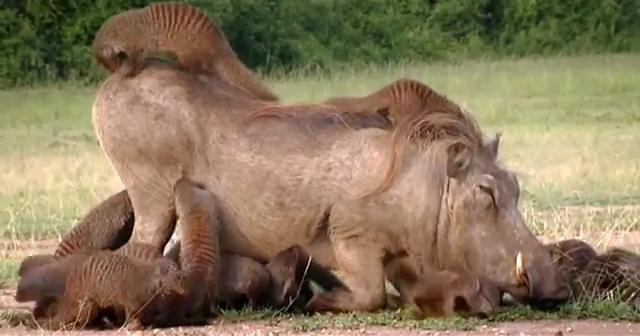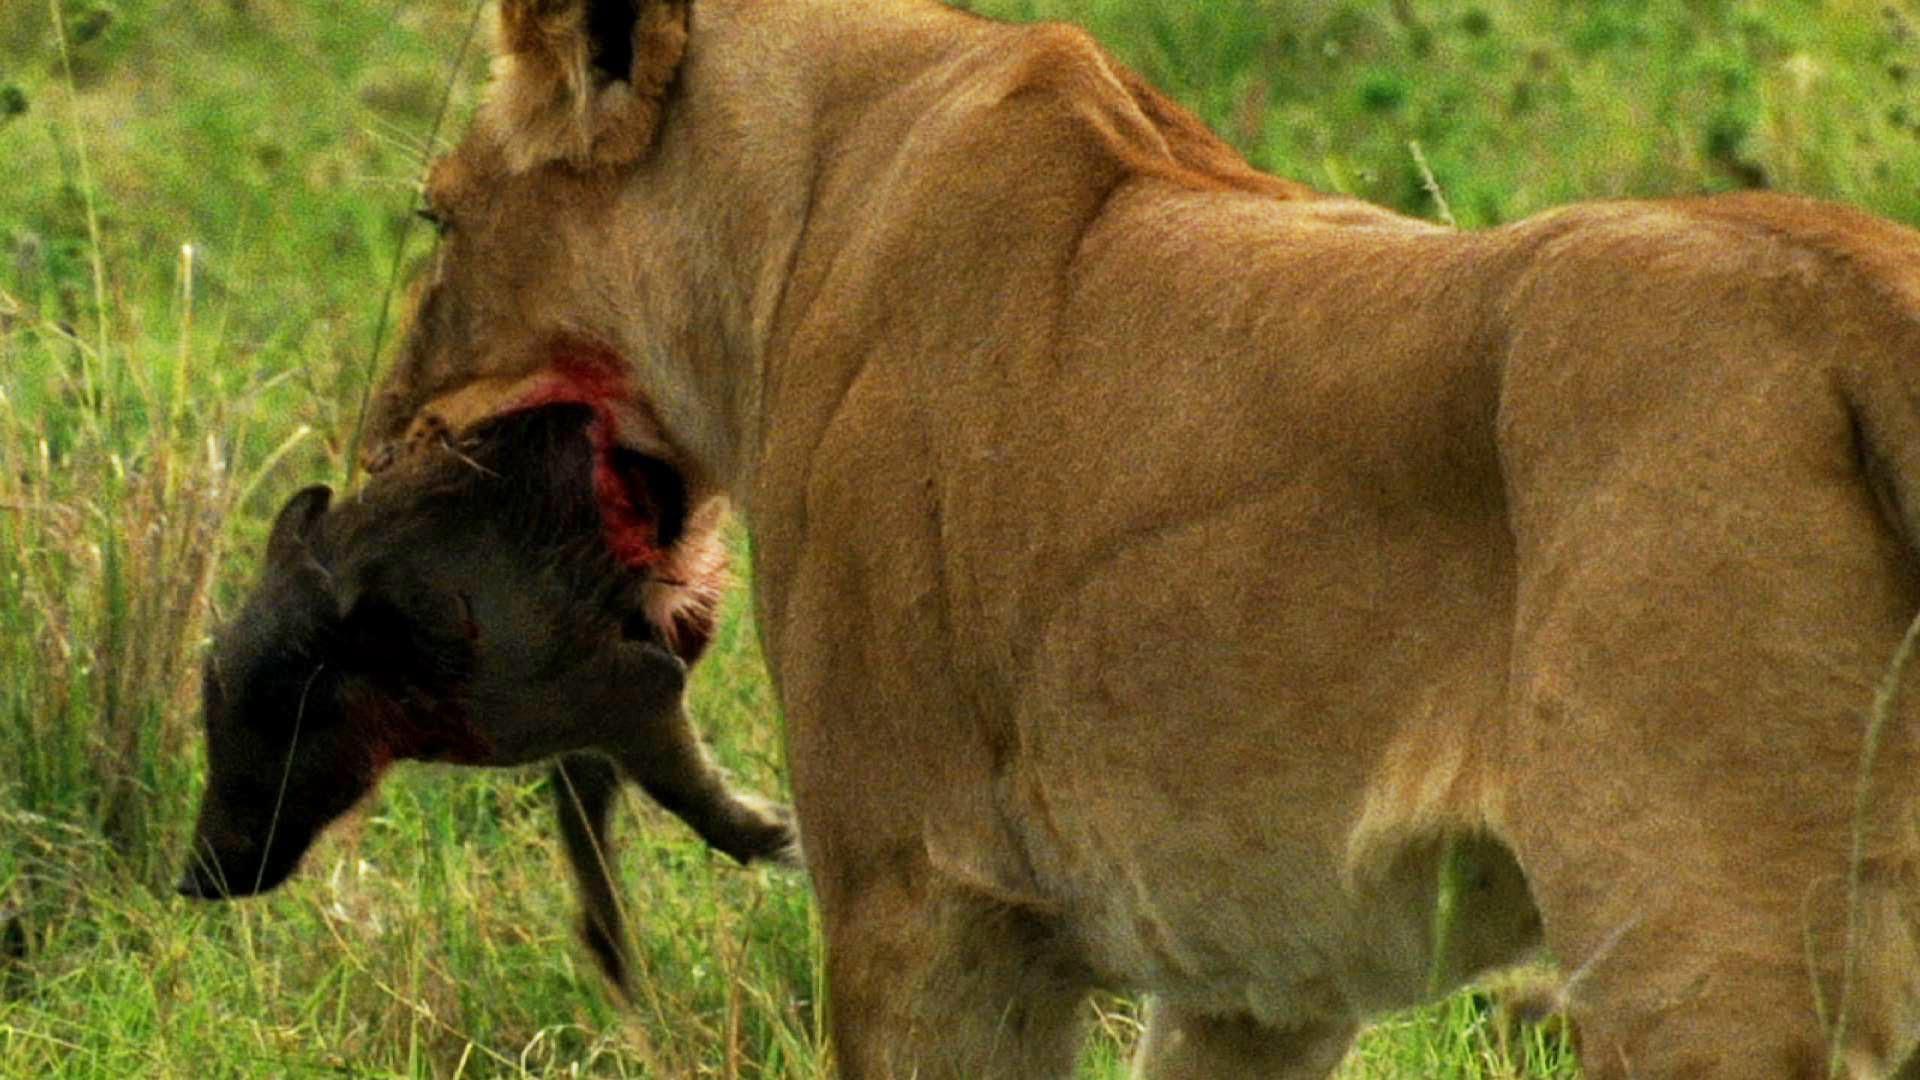The first image is the image on the left, the second image is the image on the right. For the images displayed, is the sentence "In one image, there is at least one animal on top of another one." factually correct? Answer yes or no. Yes. 